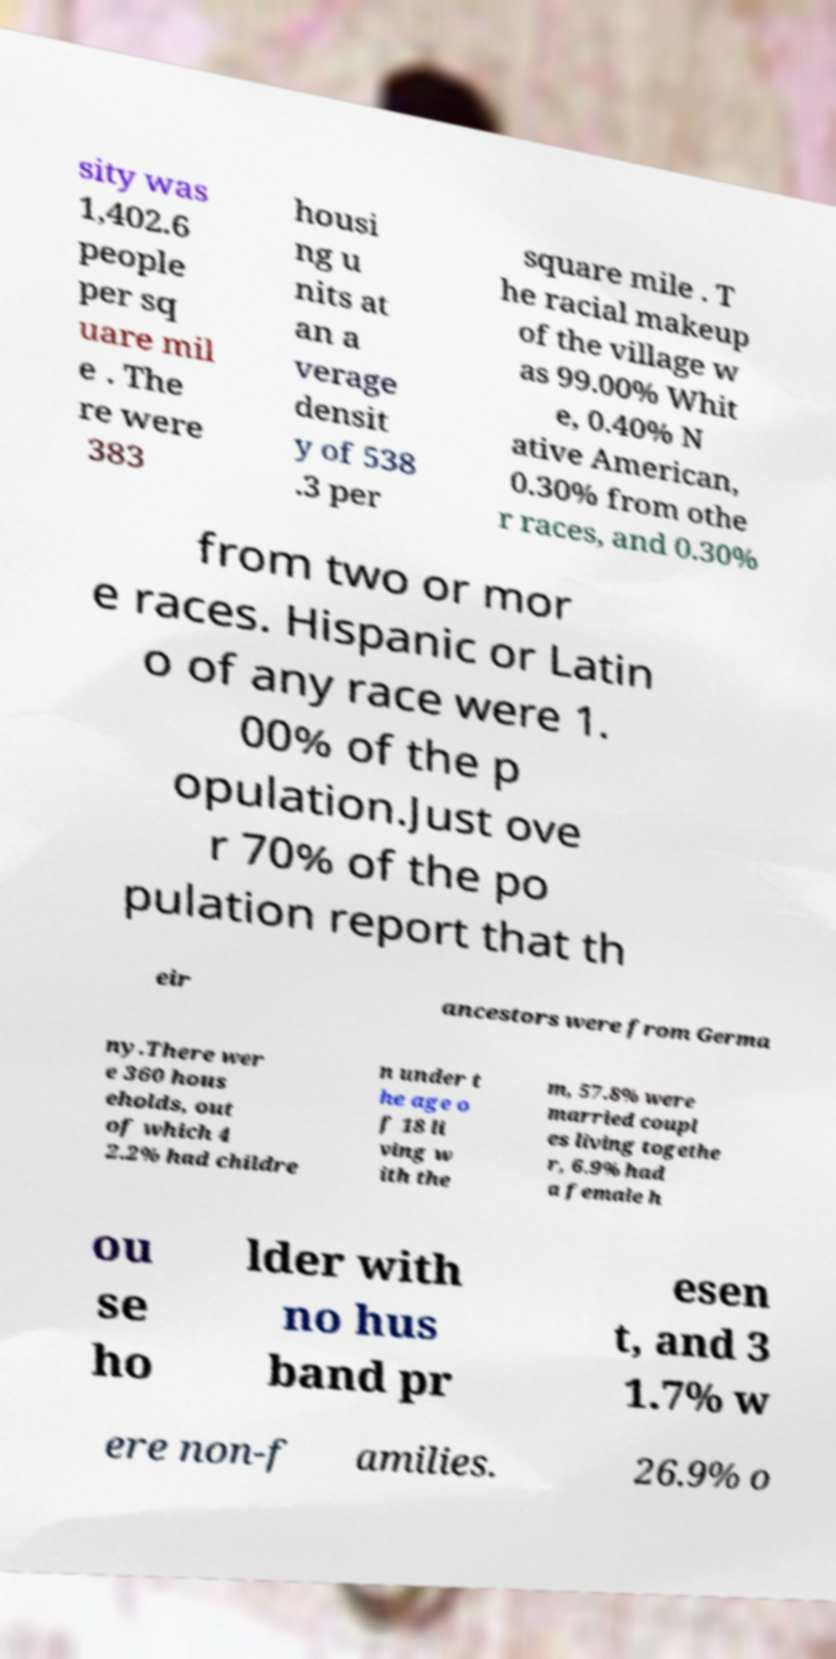Could you extract and type out the text from this image? sity was 1,402.6 people per sq uare mil e . The re were 383 housi ng u nits at an a verage densit y of 538 .3 per square mile . T he racial makeup of the village w as 99.00% Whit e, 0.40% N ative American, 0.30% from othe r races, and 0.30% from two or mor e races. Hispanic or Latin o of any race were 1. 00% of the p opulation.Just ove r 70% of the po pulation report that th eir ancestors were from Germa ny.There wer e 360 hous eholds, out of which 4 2.2% had childre n under t he age o f 18 li ving w ith the m, 57.8% were married coupl es living togethe r, 6.9% had a female h ou se ho lder with no hus band pr esen t, and 3 1.7% w ere non-f amilies. 26.9% o 